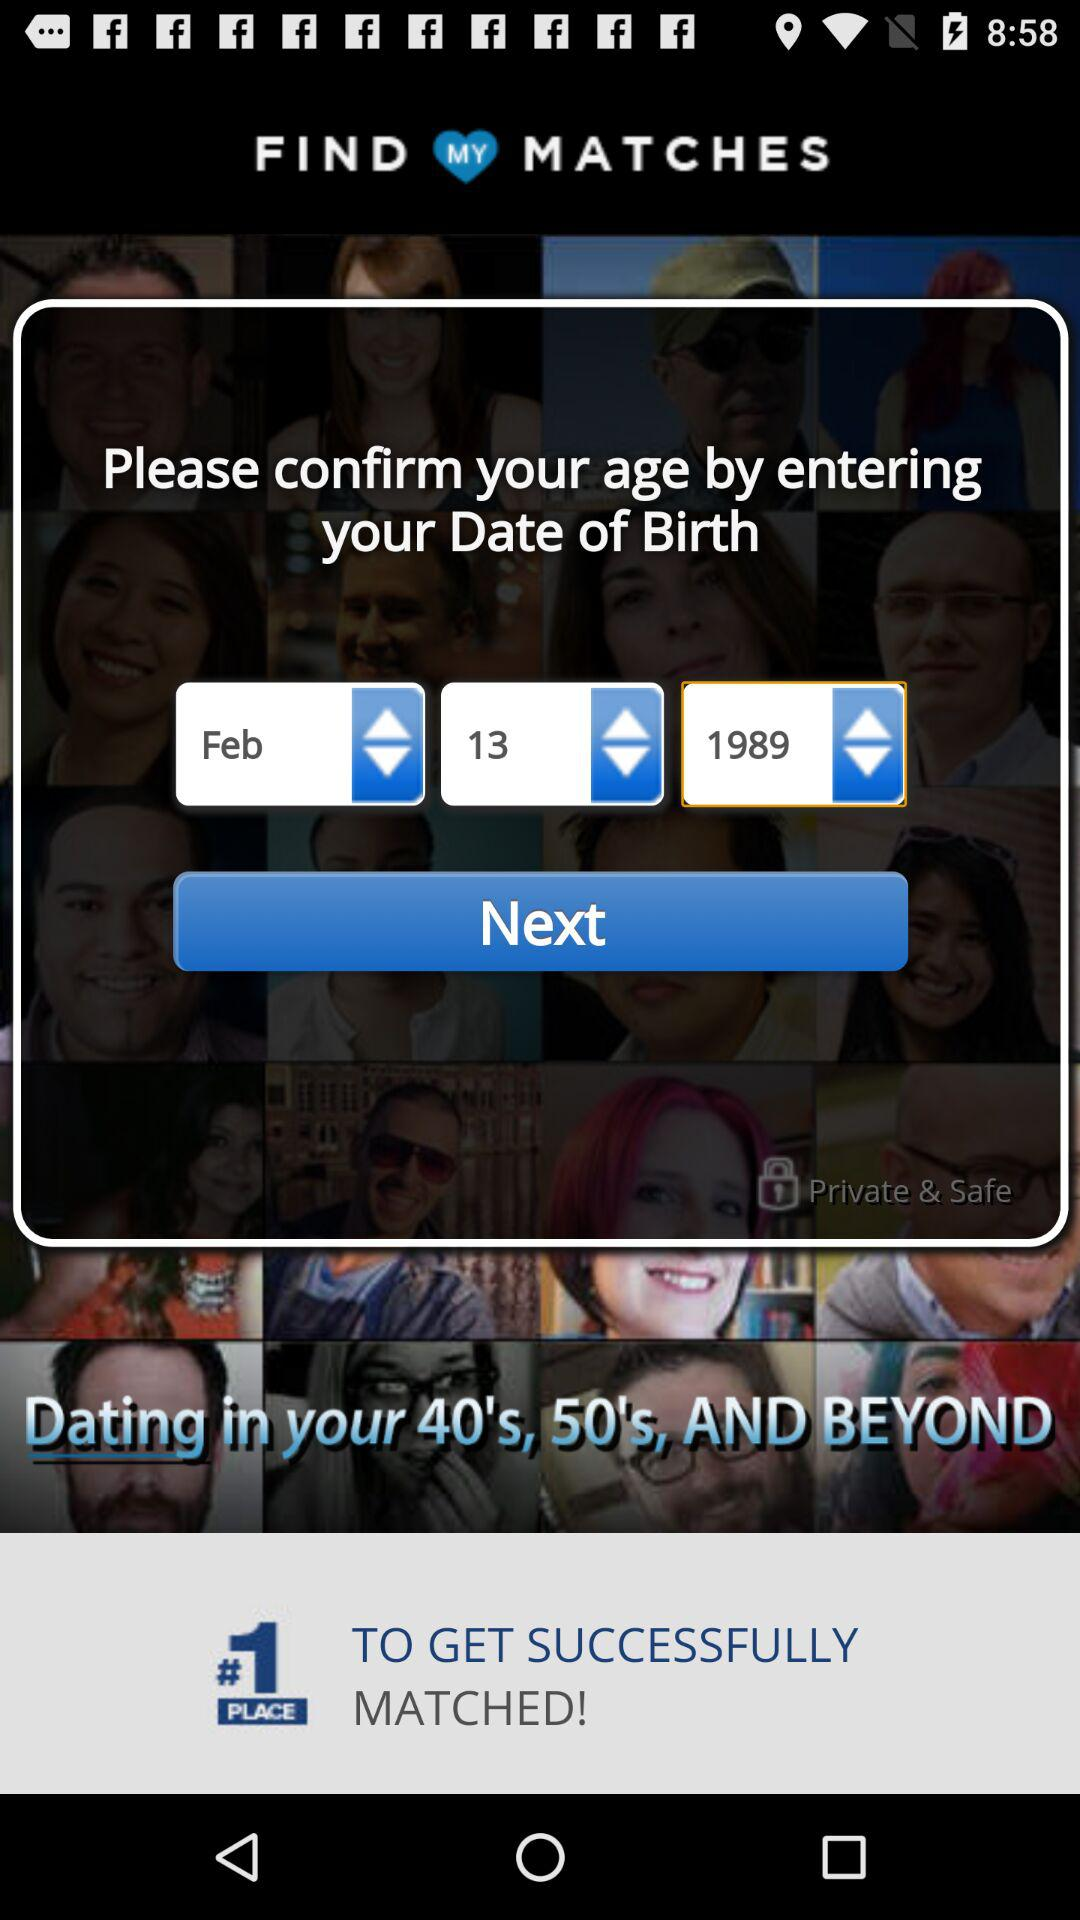How many input fields are there for the date of birth?
Answer the question using a single word or phrase. 3 